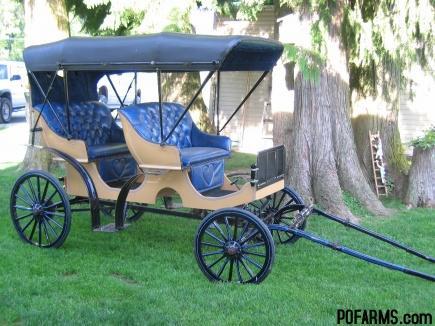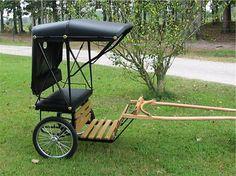The first image is the image on the left, the second image is the image on the right. Given the left and right images, does the statement "There is a human riding a carriage." hold true? Answer yes or no. No. 